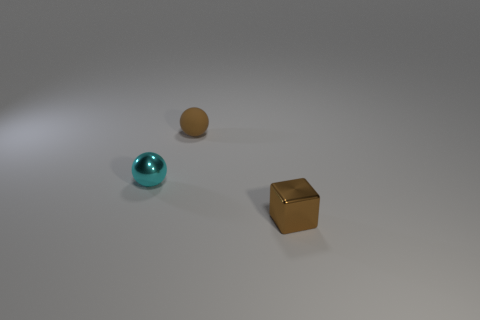Add 3 blue shiny cylinders. How many objects exist? 6 Subtract all balls. How many objects are left? 1 Subtract 0 yellow cylinders. How many objects are left? 3 Subtract all brown metallic cubes. Subtract all cubes. How many objects are left? 1 Add 1 tiny cyan balls. How many tiny cyan balls are left? 2 Add 1 shiny spheres. How many shiny spheres exist? 2 